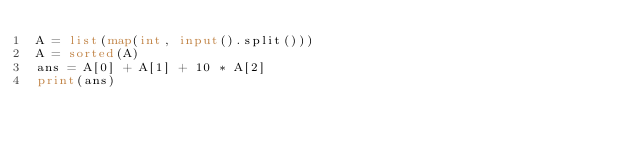Convert code to text. <code><loc_0><loc_0><loc_500><loc_500><_Python_>A = list(map(int, input().split()))
A = sorted(A)
ans = A[0] + A[1] + 10 * A[2]
print(ans)
</code> 